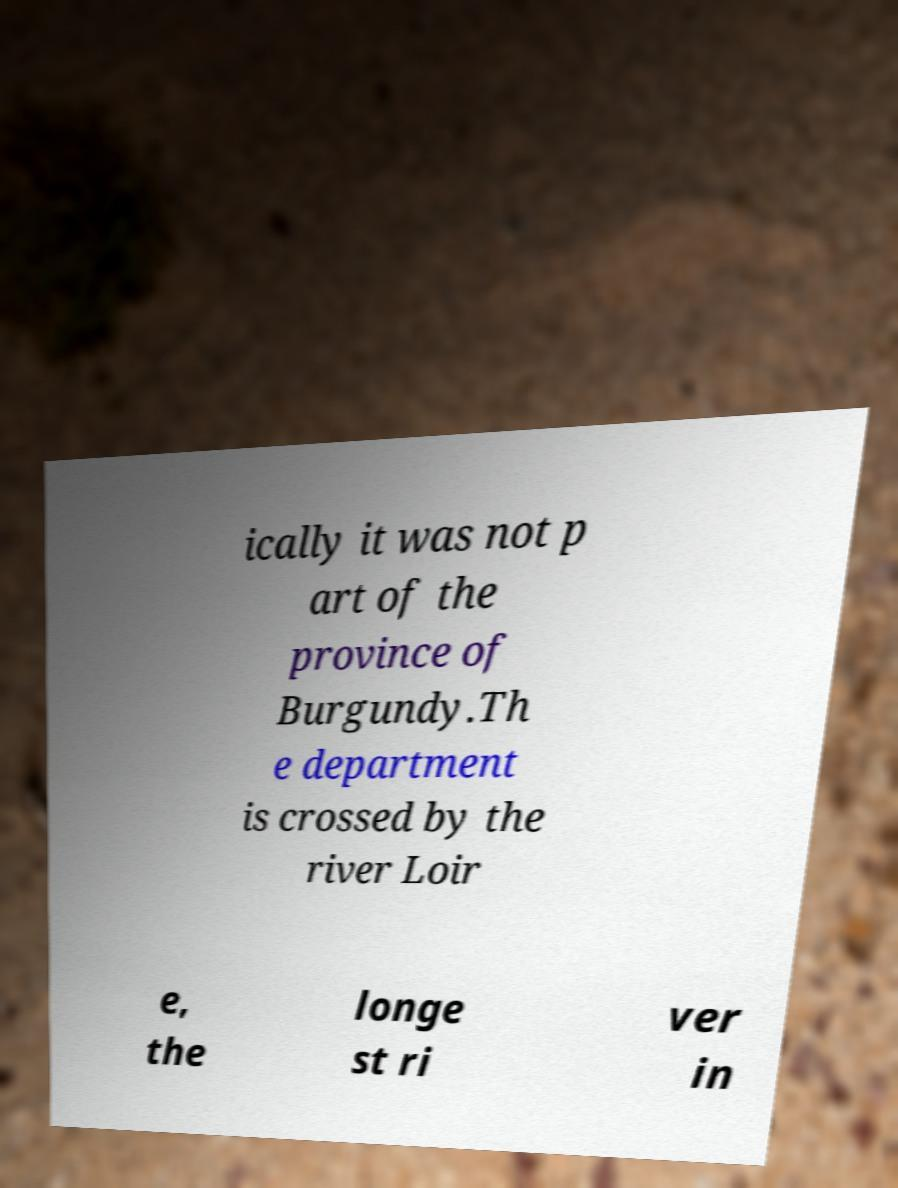Could you assist in decoding the text presented in this image and type it out clearly? ically it was not p art of the province of Burgundy.Th e department is crossed by the river Loir e, the longe st ri ver in 